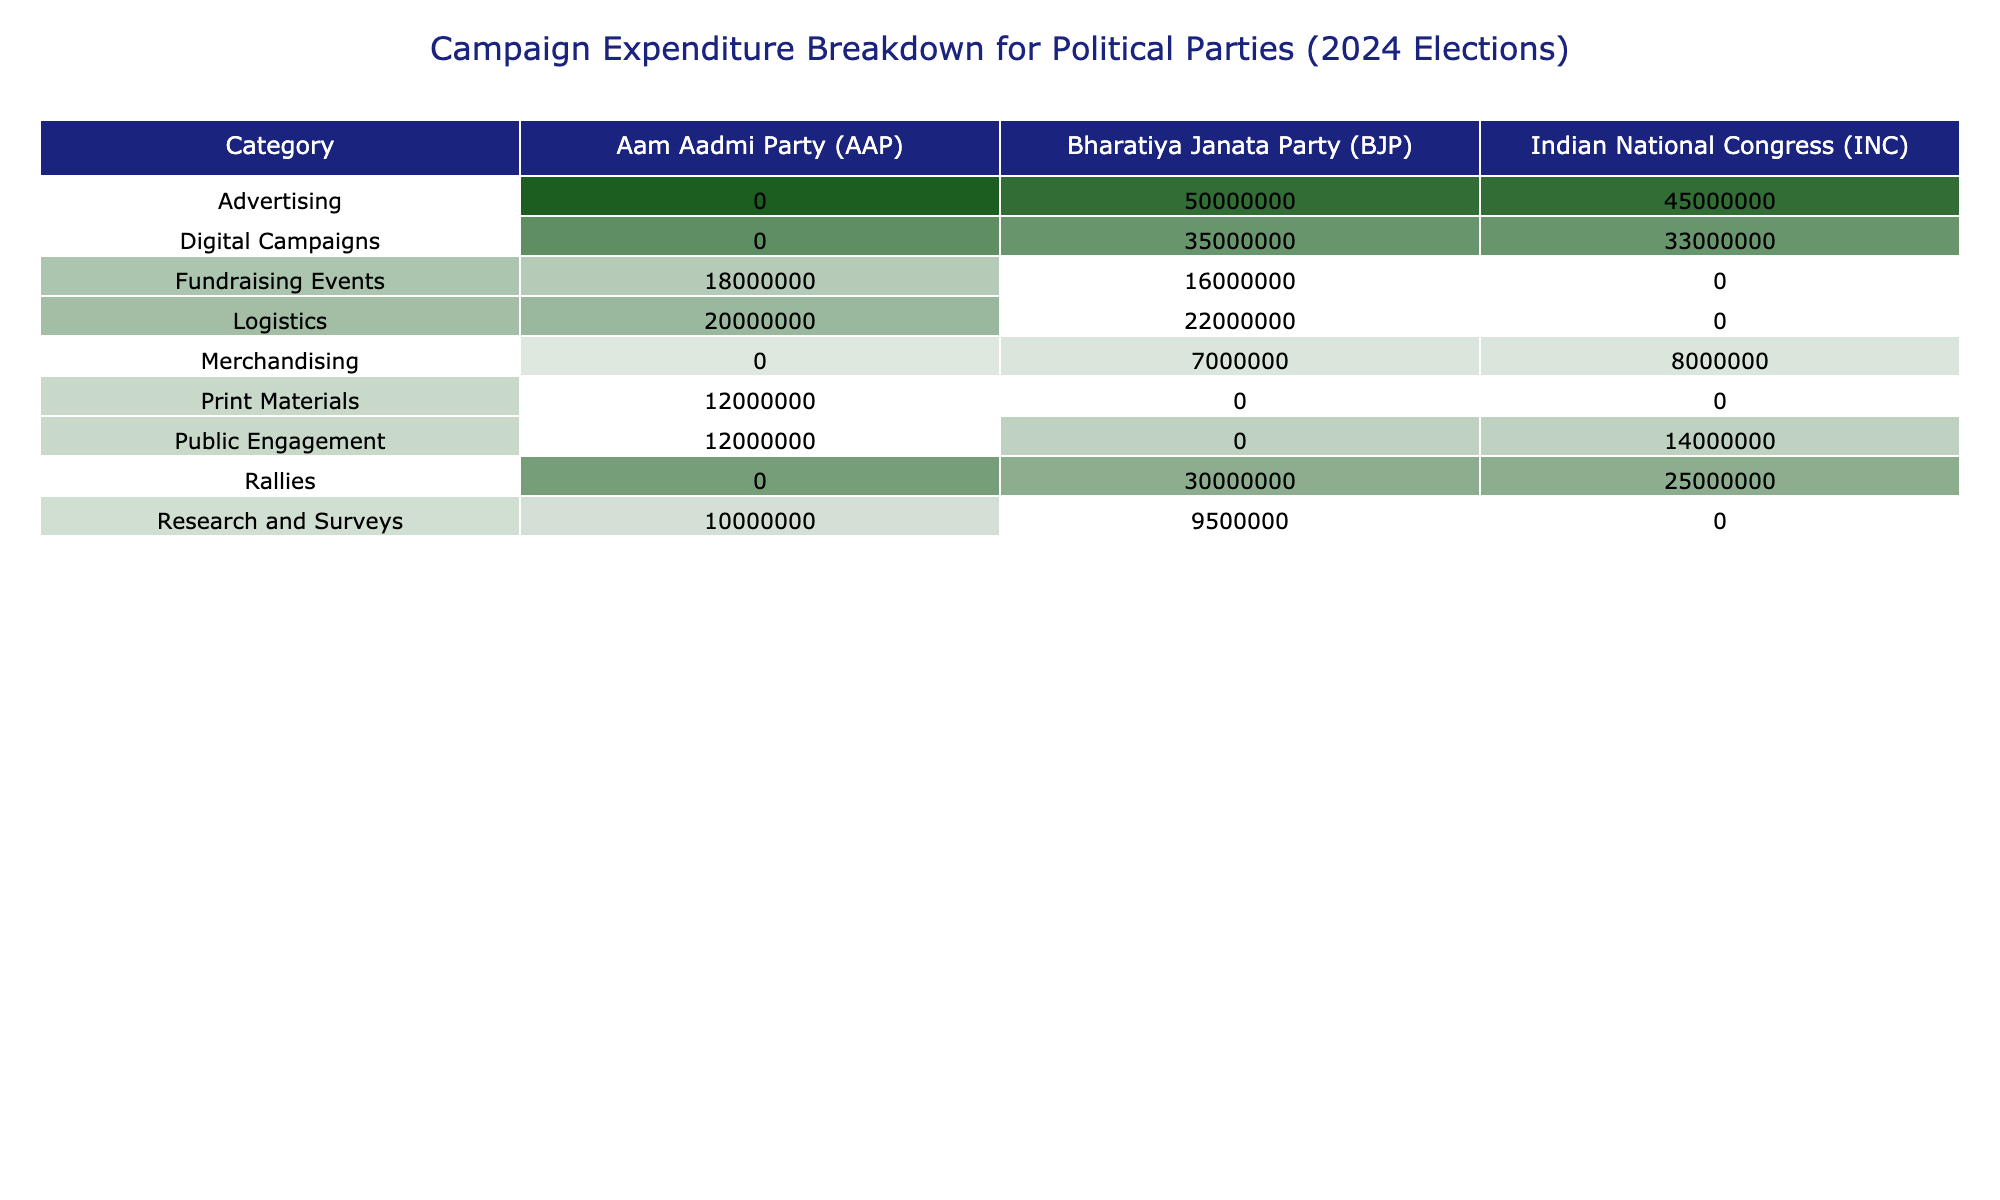What is the total campaign expenditure of the Bharatiya Janata Party (BJP)? The total campaign expenditure for the BJP can be calculated by summing the amounts from all rows where the party is BJP. The relevant amounts are 50,000,000 (Advertising) + 30,000,000 (Rallies) + 22,000,000 (Logistics) + 35,000,000 (Digital Campaigns) + 9,500,000 (Research and Surveys) + 7,000,000 (Merchandising) + 16,000,000 (Fundraising Events) = 169,500,000.
Answer: 169500000 Which party spent more on rallies, BJP or INC? For rallies, BJP spent 30,000,000 whereas INC spent 25,000,000. Since 30,000,000 is greater than 25,000,000, BJP spent more on rallies.
Answer: BJP What is the expenditure on advertising for the Indian National Congress (INC)? Looking at the Advertising category for INC, we find the amount is 45,000,000.
Answer: 45000000 What is the difference between the total amount spent by Aam Aadmi Party (AAP) and Indian National Congress (INC)? To find the difference, we first need to sum the total expenditures for each party. AAP total is 20,000,000 (Logistics) + 12,000,000 (Print Materials) + 10,000,000 (Research and Surveys) + 18,000,000 (Fundraising Events) + 12,000,000 (Public Engagement) = 72,000,000. INC total is 45,000,000 (Advertising) + 25,000,000 (Rallies) + 33,000,000 (Digital Campaigns) + 8,000,000 (Merchandising) + 14,000,000 (Public Engagement) = 125,000,000. The difference is 125,000,000 - 72,000,000 = 53,000,000.
Answer: 53000000 Did the Aam Aadmi Party (AAP) spend more on print materials than on logistics? AAP spent 12,000,000 on Print Materials and 20,000,000 on Logistics. Since 20,000,000 is greater than 12,000,000, AAP did not spend more on print materials.
Answer: No What is the average expenditure of the BJP across all categories? We first sum the amounts spent by BJP across all categories: 50,000,000 (Advertising) + 30,000,000 (Rallies) + 22,000,000 (Logistics) + 35,000,000 (Digital Campaigns) + 9,500,000 (Research and Surveys) + 7,000,000 (Merchandising) + 16,000,000 (Fundraising Events) = 169,500,000. There are 7 categories, so the average is 169,500,000 / 7 = 24,214,286, approximately.
Answer: 24214286 Which category has the highest expenditure from all parties combined? We need to sum the amounts from all parties in each category. For Advertising: 50,000,000 (BJP) + 45,000,000 (INC) = 95,000,000. For Rallies: 30,000,000 (BJP) + 25,000,000 (INC) = 55,000,000. For Logistics: 20,000,000 (AAP) + 22,000,000 (BJP) = 42,000,000. For Digital Campaigns: 35,000,000 (BJP) + 33,000,000 (INC) = 68,000,000. For Research and Surveys: 10,000,000 (AAP) + 9,500,000 (BJP) = 19,500,000. For Merchandising: 8,000,000 (INC) + 7,000,000 (BJP) = 15,000,000. For Fundraising Events: 18,000,000 (AAP) + 16,000,000 (BJP) = 34,000,000. The highest total is 95,000,000 in the Advertising category.
Answer: Advertising How much did the Aam Aadmi Party (AAP) spend overall? AAP's total expenditure can be calculated as follows: 20,000,000 (Logistics) + 12,000,000 (Print Materials) + 10,000,000 (Research and Surveys) + 18,000,000 (Fundraising Events) + 12,000,000 (Public Engagement) = 72,000,000.
Answer: 72000000 